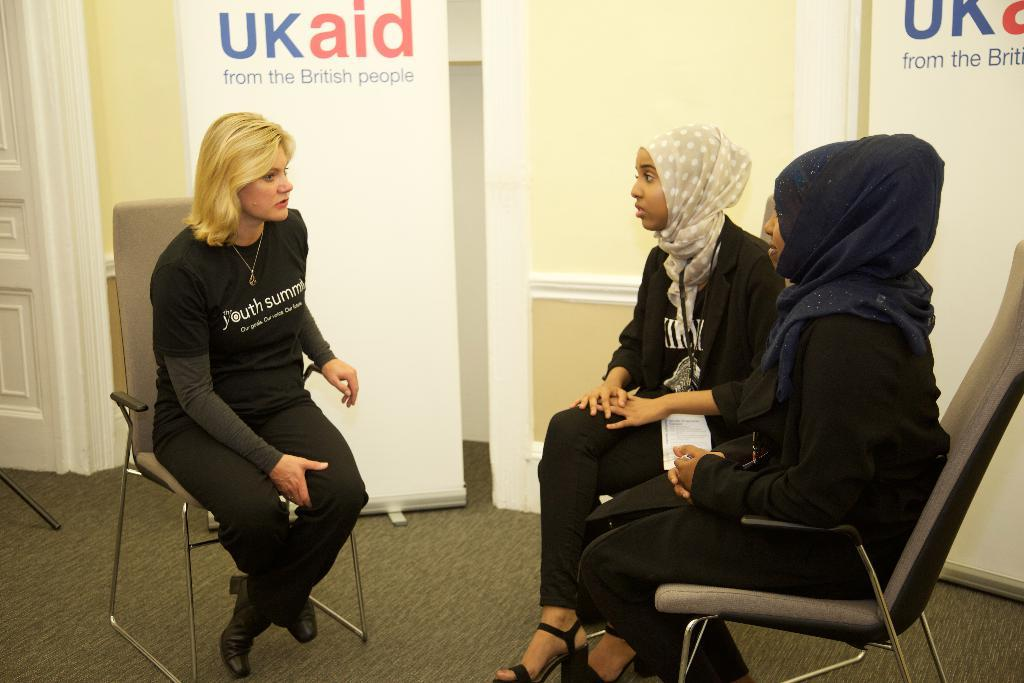How many people are sitting in the image? There are three persons sitting on chairs in the image. What can be seen in the background of the image? There is a wall, a door, and a banner in the background of the image. What rhythm does the banner have in the image? The banner does not have a rhythm in the image, as it is a static object. 